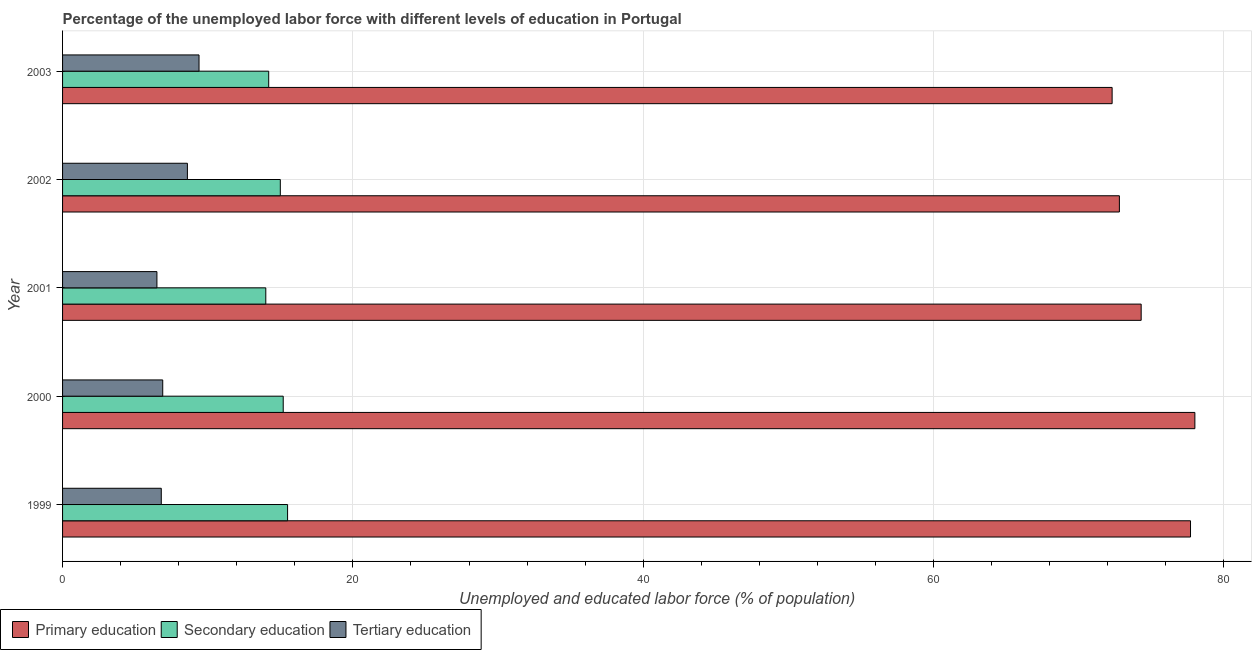Are the number of bars per tick equal to the number of legend labels?
Your response must be concise. Yes. How many bars are there on the 2nd tick from the bottom?
Ensure brevity in your answer.  3. What is the label of the 2nd group of bars from the top?
Give a very brief answer. 2002. Across all years, what is the maximum percentage of labor force who received primary education?
Keep it short and to the point. 78. Across all years, what is the minimum percentage of labor force who received secondary education?
Offer a very short reply. 14. In which year was the percentage of labor force who received primary education maximum?
Provide a succinct answer. 2000. In which year was the percentage of labor force who received tertiary education minimum?
Provide a short and direct response. 2001. What is the total percentage of labor force who received secondary education in the graph?
Give a very brief answer. 73.9. What is the difference between the percentage of labor force who received secondary education in 2002 and the percentage of labor force who received tertiary education in 1999?
Your answer should be compact. 8.2. What is the average percentage of labor force who received tertiary education per year?
Offer a very short reply. 7.64. In the year 2001, what is the difference between the percentage of labor force who received secondary education and percentage of labor force who received primary education?
Make the answer very short. -60.3. In how many years, is the percentage of labor force who received primary education greater than 12 %?
Make the answer very short. 5. What is the ratio of the percentage of labor force who received primary education in 2002 to that in 2003?
Your answer should be very brief. 1.01. Is the percentage of labor force who received tertiary education in 2001 less than that in 2003?
Make the answer very short. Yes. What is the difference between the highest and the second highest percentage of labor force who received secondary education?
Provide a short and direct response. 0.3. What is the difference between the highest and the lowest percentage of labor force who received tertiary education?
Ensure brevity in your answer.  2.9. In how many years, is the percentage of labor force who received tertiary education greater than the average percentage of labor force who received tertiary education taken over all years?
Provide a succinct answer. 2. Is the sum of the percentage of labor force who received primary education in 1999 and 2003 greater than the maximum percentage of labor force who received secondary education across all years?
Your answer should be very brief. Yes. What does the 3rd bar from the top in 2002 represents?
Provide a succinct answer. Primary education. Is it the case that in every year, the sum of the percentage of labor force who received primary education and percentage of labor force who received secondary education is greater than the percentage of labor force who received tertiary education?
Your response must be concise. Yes. How many bars are there?
Provide a short and direct response. 15. Where does the legend appear in the graph?
Your answer should be compact. Bottom left. What is the title of the graph?
Your answer should be compact. Percentage of the unemployed labor force with different levels of education in Portugal. Does "Secondary education" appear as one of the legend labels in the graph?
Offer a terse response. Yes. What is the label or title of the X-axis?
Make the answer very short. Unemployed and educated labor force (% of population). What is the Unemployed and educated labor force (% of population) in Primary education in 1999?
Your answer should be very brief. 77.7. What is the Unemployed and educated labor force (% of population) in Secondary education in 1999?
Your answer should be very brief. 15.5. What is the Unemployed and educated labor force (% of population) in Tertiary education in 1999?
Provide a succinct answer. 6.8. What is the Unemployed and educated labor force (% of population) of Secondary education in 2000?
Keep it short and to the point. 15.2. What is the Unemployed and educated labor force (% of population) of Tertiary education in 2000?
Provide a succinct answer. 6.9. What is the Unemployed and educated labor force (% of population) of Primary education in 2001?
Ensure brevity in your answer.  74.3. What is the Unemployed and educated labor force (% of population) of Primary education in 2002?
Ensure brevity in your answer.  72.8. What is the Unemployed and educated labor force (% of population) of Secondary education in 2002?
Make the answer very short. 15. What is the Unemployed and educated labor force (% of population) of Tertiary education in 2002?
Give a very brief answer. 8.6. What is the Unemployed and educated labor force (% of population) of Primary education in 2003?
Make the answer very short. 72.3. What is the Unemployed and educated labor force (% of population) of Secondary education in 2003?
Your response must be concise. 14.2. What is the Unemployed and educated labor force (% of population) in Tertiary education in 2003?
Your answer should be very brief. 9.4. Across all years, what is the maximum Unemployed and educated labor force (% of population) of Primary education?
Offer a very short reply. 78. Across all years, what is the maximum Unemployed and educated labor force (% of population) of Tertiary education?
Provide a short and direct response. 9.4. Across all years, what is the minimum Unemployed and educated labor force (% of population) of Primary education?
Keep it short and to the point. 72.3. Across all years, what is the minimum Unemployed and educated labor force (% of population) in Secondary education?
Your response must be concise. 14. What is the total Unemployed and educated labor force (% of population) in Primary education in the graph?
Offer a very short reply. 375.1. What is the total Unemployed and educated labor force (% of population) in Secondary education in the graph?
Ensure brevity in your answer.  73.9. What is the total Unemployed and educated labor force (% of population) of Tertiary education in the graph?
Your answer should be very brief. 38.2. What is the difference between the Unemployed and educated labor force (% of population) in Primary education in 1999 and that in 2000?
Provide a succinct answer. -0.3. What is the difference between the Unemployed and educated labor force (% of population) of Primary education in 1999 and that in 2001?
Provide a short and direct response. 3.4. What is the difference between the Unemployed and educated labor force (% of population) of Tertiary education in 1999 and that in 2001?
Provide a succinct answer. 0.3. What is the difference between the Unemployed and educated labor force (% of population) of Primary education in 1999 and that in 2002?
Your answer should be very brief. 4.9. What is the difference between the Unemployed and educated labor force (% of population) of Tertiary education in 1999 and that in 2002?
Your answer should be very brief. -1.8. What is the difference between the Unemployed and educated labor force (% of population) of Secondary education in 1999 and that in 2003?
Provide a short and direct response. 1.3. What is the difference between the Unemployed and educated labor force (% of population) of Secondary education in 2000 and that in 2001?
Make the answer very short. 1.2. What is the difference between the Unemployed and educated labor force (% of population) in Tertiary education in 2000 and that in 2001?
Ensure brevity in your answer.  0.4. What is the difference between the Unemployed and educated labor force (% of population) in Tertiary education in 2000 and that in 2002?
Your answer should be very brief. -1.7. What is the difference between the Unemployed and educated labor force (% of population) of Primary education in 2000 and that in 2003?
Keep it short and to the point. 5.7. What is the difference between the Unemployed and educated labor force (% of population) in Secondary education in 2000 and that in 2003?
Offer a very short reply. 1. What is the difference between the Unemployed and educated labor force (% of population) in Tertiary education in 2000 and that in 2003?
Make the answer very short. -2.5. What is the difference between the Unemployed and educated labor force (% of population) of Primary education in 2001 and that in 2002?
Your answer should be very brief. 1.5. What is the difference between the Unemployed and educated labor force (% of population) of Secondary education in 2001 and that in 2002?
Make the answer very short. -1. What is the difference between the Unemployed and educated labor force (% of population) in Tertiary education in 2001 and that in 2002?
Offer a terse response. -2.1. What is the difference between the Unemployed and educated labor force (% of population) in Secondary education in 2001 and that in 2003?
Your answer should be very brief. -0.2. What is the difference between the Unemployed and educated labor force (% of population) of Tertiary education in 2001 and that in 2003?
Give a very brief answer. -2.9. What is the difference between the Unemployed and educated labor force (% of population) of Primary education in 2002 and that in 2003?
Provide a succinct answer. 0.5. What is the difference between the Unemployed and educated labor force (% of population) in Secondary education in 2002 and that in 2003?
Make the answer very short. 0.8. What is the difference between the Unemployed and educated labor force (% of population) in Tertiary education in 2002 and that in 2003?
Your answer should be very brief. -0.8. What is the difference between the Unemployed and educated labor force (% of population) in Primary education in 1999 and the Unemployed and educated labor force (% of population) in Secondary education in 2000?
Give a very brief answer. 62.5. What is the difference between the Unemployed and educated labor force (% of population) of Primary education in 1999 and the Unemployed and educated labor force (% of population) of Tertiary education in 2000?
Provide a short and direct response. 70.8. What is the difference between the Unemployed and educated labor force (% of population) in Primary education in 1999 and the Unemployed and educated labor force (% of population) in Secondary education in 2001?
Your response must be concise. 63.7. What is the difference between the Unemployed and educated labor force (% of population) in Primary education in 1999 and the Unemployed and educated labor force (% of population) in Tertiary education in 2001?
Your answer should be very brief. 71.2. What is the difference between the Unemployed and educated labor force (% of population) of Primary education in 1999 and the Unemployed and educated labor force (% of population) of Secondary education in 2002?
Provide a succinct answer. 62.7. What is the difference between the Unemployed and educated labor force (% of population) of Primary education in 1999 and the Unemployed and educated labor force (% of population) of Tertiary education in 2002?
Make the answer very short. 69.1. What is the difference between the Unemployed and educated labor force (% of population) in Secondary education in 1999 and the Unemployed and educated labor force (% of population) in Tertiary education in 2002?
Provide a short and direct response. 6.9. What is the difference between the Unemployed and educated labor force (% of population) of Primary education in 1999 and the Unemployed and educated labor force (% of population) of Secondary education in 2003?
Ensure brevity in your answer.  63.5. What is the difference between the Unemployed and educated labor force (% of population) in Primary education in 1999 and the Unemployed and educated labor force (% of population) in Tertiary education in 2003?
Ensure brevity in your answer.  68.3. What is the difference between the Unemployed and educated labor force (% of population) of Secondary education in 1999 and the Unemployed and educated labor force (% of population) of Tertiary education in 2003?
Your answer should be compact. 6.1. What is the difference between the Unemployed and educated labor force (% of population) of Primary education in 2000 and the Unemployed and educated labor force (% of population) of Tertiary education in 2001?
Give a very brief answer. 71.5. What is the difference between the Unemployed and educated labor force (% of population) in Primary education in 2000 and the Unemployed and educated labor force (% of population) in Secondary education in 2002?
Your answer should be compact. 63. What is the difference between the Unemployed and educated labor force (% of population) of Primary education in 2000 and the Unemployed and educated labor force (% of population) of Tertiary education in 2002?
Provide a succinct answer. 69.4. What is the difference between the Unemployed and educated labor force (% of population) of Secondary education in 2000 and the Unemployed and educated labor force (% of population) of Tertiary education in 2002?
Ensure brevity in your answer.  6.6. What is the difference between the Unemployed and educated labor force (% of population) in Primary education in 2000 and the Unemployed and educated labor force (% of population) in Secondary education in 2003?
Give a very brief answer. 63.8. What is the difference between the Unemployed and educated labor force (% of population) in Primary education in 2000 and the Unemployed and educated labor force (% of population) in Tertiary education in 2003?
Your response must be concise. 68.6. What is the difference between the Unemployed and educated labor force (% of population) of Primary education in 2001 and the Unemployed and educated labor force (% of population) of Secondary education in 2002?
Your response must be concise. 59.3. What is the difference between the Unemployed and educated labor force (% of population) of Primary education in 2001 and the Unemployed and educated labor force (% of population) of Tertiary education in 2002?
Provide a succinct answer. 65.7. What is the difference between the Unemployed and educated labor force (% of population) in Secondary education in 2001 and the Unemployed and educated labor force (% of population) in Tertiary education in 2002?
Make the answer very short. 5.4. What is the difference between the Unemployed and educated labor force (% of population) in Primary education in 2001 and the Unemployed and educated labor force (% of population) in Secondary education in 2003?
Give a very brief answer. 60.1. What is the difference between the Unemployed and educated labor force (% of population) in Primary education in 2001 and the Unemployed and educated labor force (% of population) in Tertiary education in 2003?
Ensure brevity in your answer.  64.9. What is the difference between the Unemployed and educated labor force (% of population) in Secondary education in 2001 and the Unemployed and educated labor force (% of population) in Tertiary education in 2003?
Your response must be concise. 4.6. What is the difference between the Unemployed and educated labor force (% of population) of Primary education in 2002 and the Unemployed and educated labor force (% of population) of Secondary education in 2003?
Provide a short and direct response. 58.6. What is the difference between the Unemployed and educated labor force (% of population) in Primary education in 2002 and the Unemployed and educated labor force (% of population) in Tertiary education in 2003?
Provide a succinct answer. 63.4. What is the difference between the Unemployed and educated labor force (% of population) of Secondary education in 2002 and the Unemployed and educated labor force (% of population) of Tertiary education in 2003?
Ensure brevity in your answer.  5.6. What is the average Unemployed and educated labor force (% of population) of Primary education per year?
Your answer should be compact. 75.02. What is the average Unemployed and educated labor force (% of population) in Secondary education per year?
Offer a terse response. 14.78. What is the average Unemployed and educated labor force (% of population) in Tertiary education per year?
Your response must be concise. 7.64. In the year 1999, what is the difference between the Unemployed and educated labor force (% of population) of Primary education and Unemployed and educated labor force (% of population) of Secondary education?
Provide a short and direct response. 62.2. In the year 1999, what is the difference between the Unemployed and educated labor force (% of population) in Primary education and Unemployed and educated labor force (% of population) in Tertiary education?
Offer a terse response. 70.9. In the year 1999, what is the difference between the Unemployed and educated labor force (% of population) of Secondary education and Unemployed and educated labor force (% of population) of Tertiary education?
Your answer should be very brief. 8.7. In the year 2000, what is the difference between the Unemployed and educated labor force (% of population) of Primary education and Unemployed and educated labor force (% of population) of Secondary education?
Your answer should be compact. 62.8. In the year 2000, what is the difference between the Unemployed and educated labor force (% of population) of Primary education and Unemployed and educated labor force (% of population) of Tertiary education?
Offer a very short reply. 71.1. In the year 2001, what is the difference between the Unemployed and educated labor force (% of population) of Primary education and Unemployed and educated labor force (% of population) of Secondary education?
Ensure brevity in your answer.  60.3. In the year 2001, what is the difference between the Unemployed and educated labor force (% of population) of Primary education and Unemployed and educated labor force (% of population) of Tertiary education?
Ensure brevity in your answer.  67.8. In the year 2002, what is the difference between the Unemployed and educated labor force (% of population) of Primary education and Unemployed and educated labor force (% of population) of Secondary education?
Your answer should be very brief. 57.8. In the year 2002, what is the difference between the Unemployed and educated labor force (% of population) of Primary education and Unemployed and educated labor force (% of population) of Tertiary education?
Offer a terse response. 64.2. In the year 2003, what is the difference between the Unemployed and educated labor force (% of population) of Primary education and Unemployed and educated labor force (% of population) of Secondary education?
Your response must be concise. 58.1. In the year 2003, what is the difference between the Unemployed and educated labor force (% of population) in Primary education and Unemployed and educated labor force (% of population) in Tertiary education?
Provide a short and direct response. 62.9. What is the ratio of the Unemployed and educated labor force (% of population) of Primary education in 1999 to that in 2000?
Offer a terse response. 1. What is the ratio of the Unemployed and educated labor force (% of population) of Secondary education in 1999 to that in 2000?
Provide a succinct answer. 1.02. What is the ratio of the Unemployed and educated labor force (% of population) in Tertiary education in 1999 to that in 2000?
Your response must be concise. 0.99. What is the ratio of the Unemployed and educated labor force (% of population) in Primary education in 1999 to that in 2001?
Your response must be concise. 1.05. What is the ratio of the Unemployed and educated labor force (% of population) of Secondary education in 1999 to that in 2001?
Provide a succinct answer. 1.11. What is the ratio of the Unemployed and educated labor force (% of population) in Tertiary education in 1999 to that in 2001?
Ensure brevity in your answer.  1.05. What is the ratio of the Unemployed and educated labor force (% of population) in Primary education in 1999 to that in 2002?
Provide a short and direct response. 1.07. What is the ratio of the Unemployed and educated labor force (% of population) in Tertiary education in 1999 to that in 2002?
Make the answer very short. 0.79. What is the ratio of the Unemployed and educated labor force (% of population) in Primary education in 1999 to that in 2003?
Keep it short and to the point. 1.07. What is the ratio of the Unemployed and educated labor force (% of population) of Secondary education in 1999 to that in 2003?
Your answer should be very brief. 1.09. What is the ratio of the Unemployed and educated labor force (% of population) of Tertiary education in 1999 to that in 2003?
Give a very brief answer. 0.72. What is the ratio of the Unemployed and educated labor force (% of population) of Primary education in 2000 to that in 2001?
Offer a terse response. 1.05. What is the ratio of the Unemployed and educated labor force (% of population) of Secondary education in 2000 to that in 2001?
Your answer should be very brief. 1.09. What is the ratio of the Unemployed and educated labor force (% of population) of Tertiary education in 2000 to that in 2001?
Offer a terse response. 1.06. What is the ratio of the Unemployed and educated labor force (% of population) of Primary education in 2000 to that in 2002?
Offer a terse response. 1.07. What is the ratio of the Unemployed and educated labor force (% of population) of Secondary education in 2000 to that in 2002?
Offer a very short reply. 1.01. What is the ratio of the Unemployed and educated labor force (% of population) of Tertiary education in 2000 to that in 2002?
Give a very brief answer. 0.8. What is the ratio of the Unemployed and educated labor force (% of population) of Primary education in 2000 to that in 2003?
Ensure brevity in your answer.  1.08. What is the ratio of the Unemployed and educated labor force (% of population) of Secondary education in 2000 to that in 2003?
Offer a very short reply. 1.07. What is the ratio of the Unemployed and educated labor force (% of population) of Tertiary education in 2000 to that in 2003?
Provide a short and direct response. 0.73. What is the ratio of the Unemployed and educated labor force (% of population) of Primary education in 2001 to that in 2002?
Give a very brief answer. 1.02. What is the ratio of the Unemployed and educated labor force (% of population) of Tertiary education in 2001 to that in 2002?
Your response must be concise. 0.76. What is the ratio of the Unemployed and educated labor force (% of population) of Primary education in 2001 to that in 2003?
Offer a very short reply. 1.03. What is the ratio of the Unemployed and educated labor force (% of population) of Secondary education in 2001 to that in 2003?
Keep it short and to the point. 0.99. What is the ratio of the Unemployed and educated labor force (% of population) in Tertiary education in 2001 to that in 2003?
Your answer should be very brief. 0.69. What is the ratio of the Unemployed and educated labor force (% of population) of Secondary education in 2002 to that in 2003?
Offer a very short reply. 1.06. What is the ratio of the Unemployed and educated labor force (% of population) of Tertiary education in 2002 to that in 2003?
Your answer should be compact. 0.91. What is the difference between the highest and the second highest Unemployed and educated labor force (% of population) of Primary education?
Keep it short and to the point. 0.3. What is the difference between the highest and the lowest Unemployed and educated labor force (% of population) in Tertiary education?
Give a very brief answer. 2.9. 